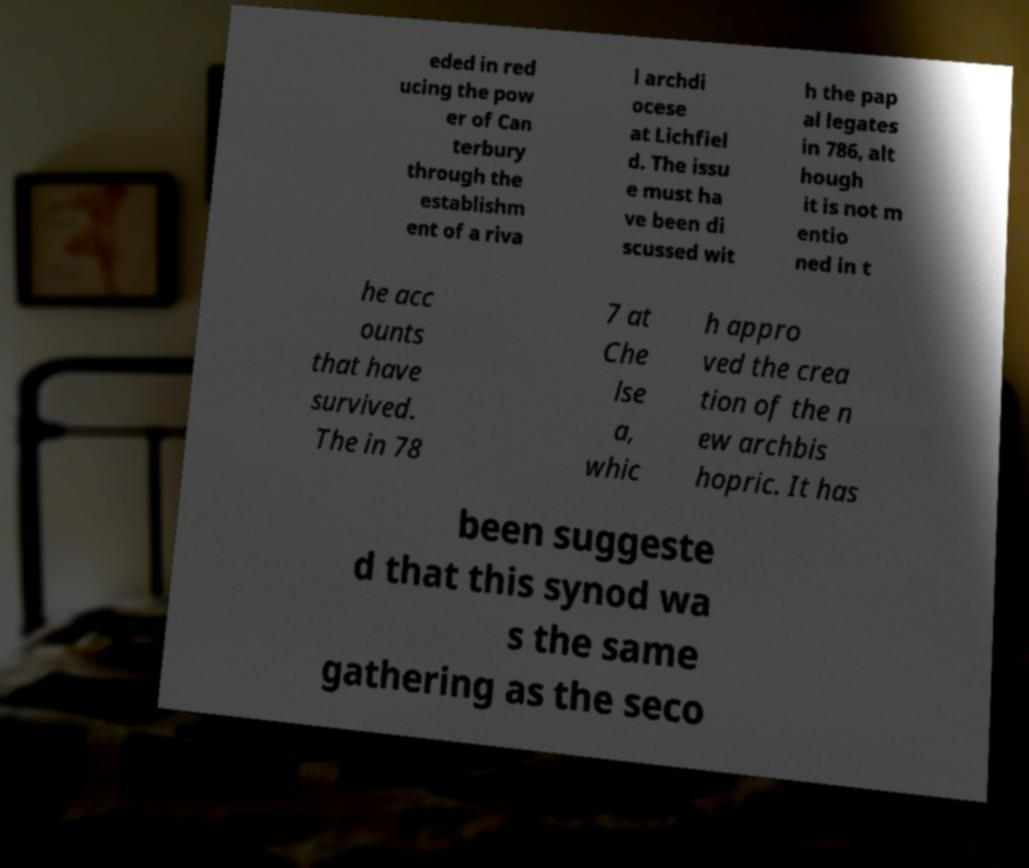There's text embedded in this image that I need extracted. Can you transcribe it verbatim? eded in red ucing the pow er of Can terbury through the establishm ent of a riva l archdi ocese at Lichfiel d. The issu e must ha ve been di scussed wit h the pap al legates in 786, alt hough it is not m entio ned in t he acc ounts that have survived. The in 78 7 at Che lse a, whic h appro ved the crea tion of the n ew archbis hopric. It has been suggeste d that this synod wa s the same gathering as the seco 